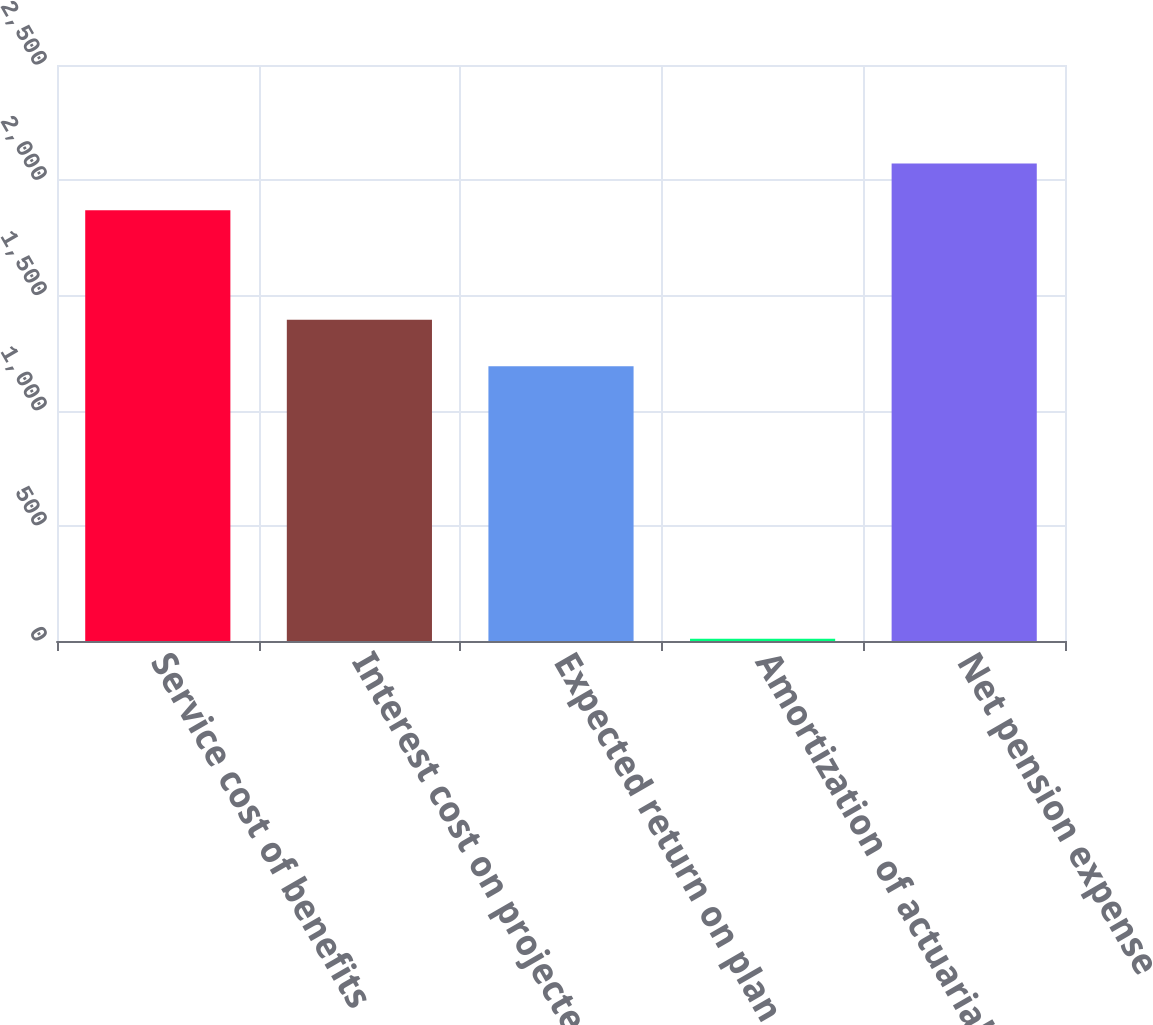Convert chart. <chart><loc_0><loc_0><loc_500><loc_500><bar_chart><fcel>Service cost of benefits<fcel>Interest cost on projected<fcel>Expected return on plan assets<fcel>Amortization of actuarial loss<fcel>Net pension expense<nl><fcel>1870<fcel>1394.5<fcel>1192<fcel>10<fcel>2072.5<nl></chart> 